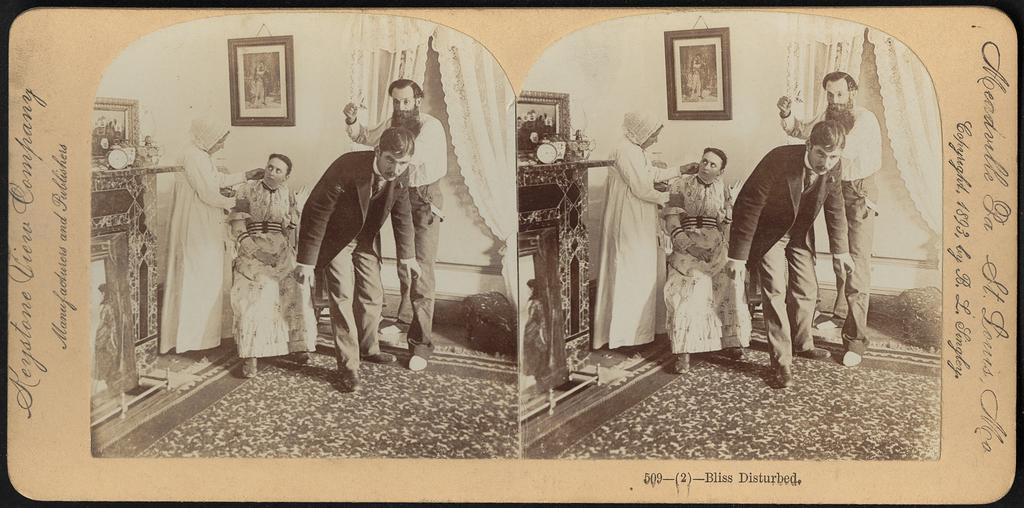What type of images are present in the image? There are two black and white pictures in the image. Can you describe the text on the image? Text is written on both sides of the image. How many fingers can be seen in the image? There is no mention of fingers in the image, as it only contains two black and white pictures and text. 